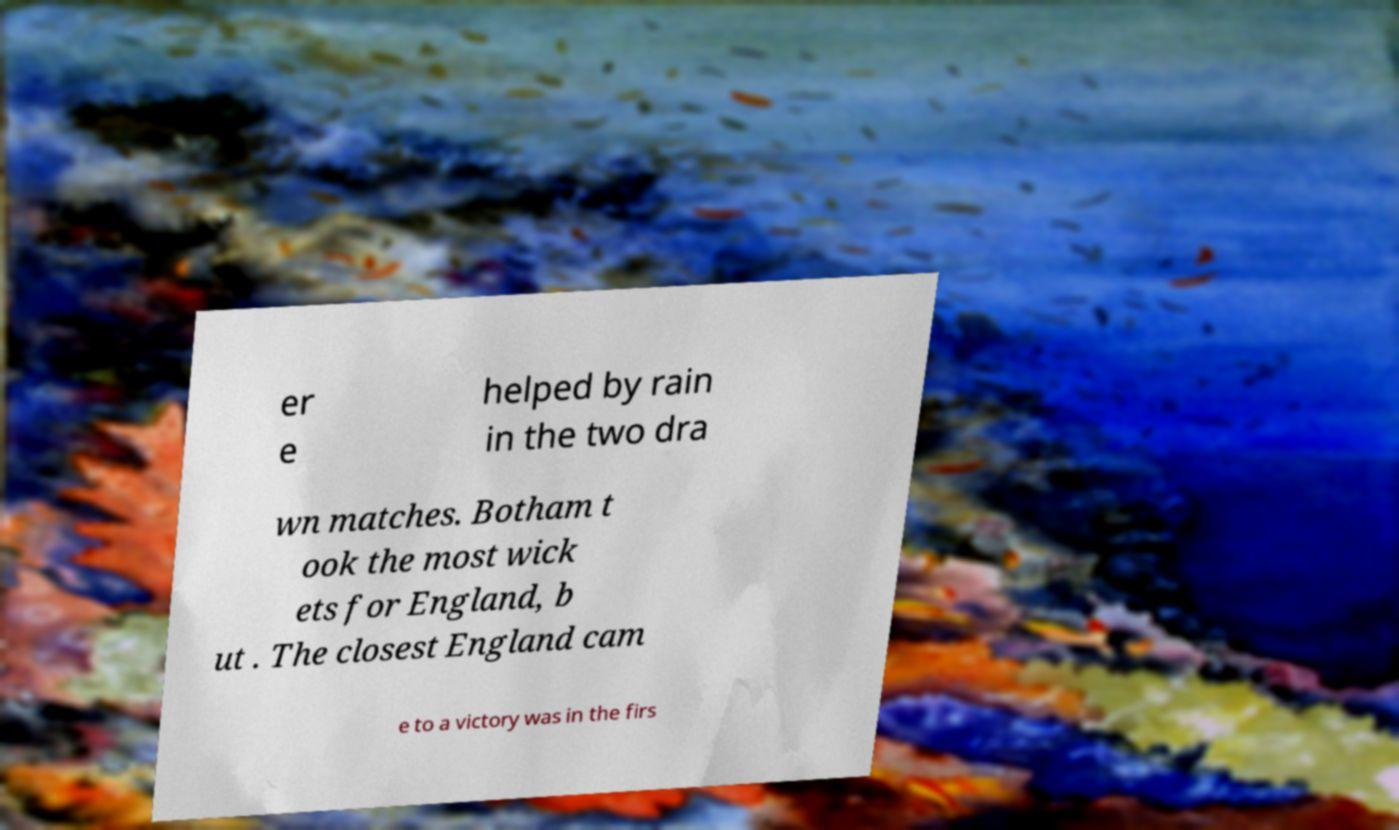I need the written content from this picture converted into text. Can you do that? er e helped by rain in the two dra wn matches. Botham t ook the most wick ets for England, b ut . The closest England cam e to a victory was in the firs 